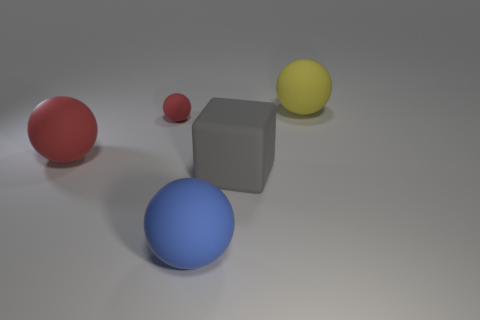Subtract all big yellow spheres. How many spheres are left? 3 Subtract all blue spheres. How many spheres are left? 3 Add 2 small balls. How many objects exist? 7 Subtract all cubes. How many objects are left? 4 Add 2 large matte objects. How many large matte objects exist? 6 Subtract 1 yellow balls. How many objects are left? 4 Subtract 1 balls. How many balls are left? 3 Subtract all green cubes. Subtract all yellow cylinders. How many cubes are left? 1 Subtract all gray balls. How many blue cubes are left? 0 Subtract all large blue balls. Subtract all small rubber objects. How many objects are left? 3 